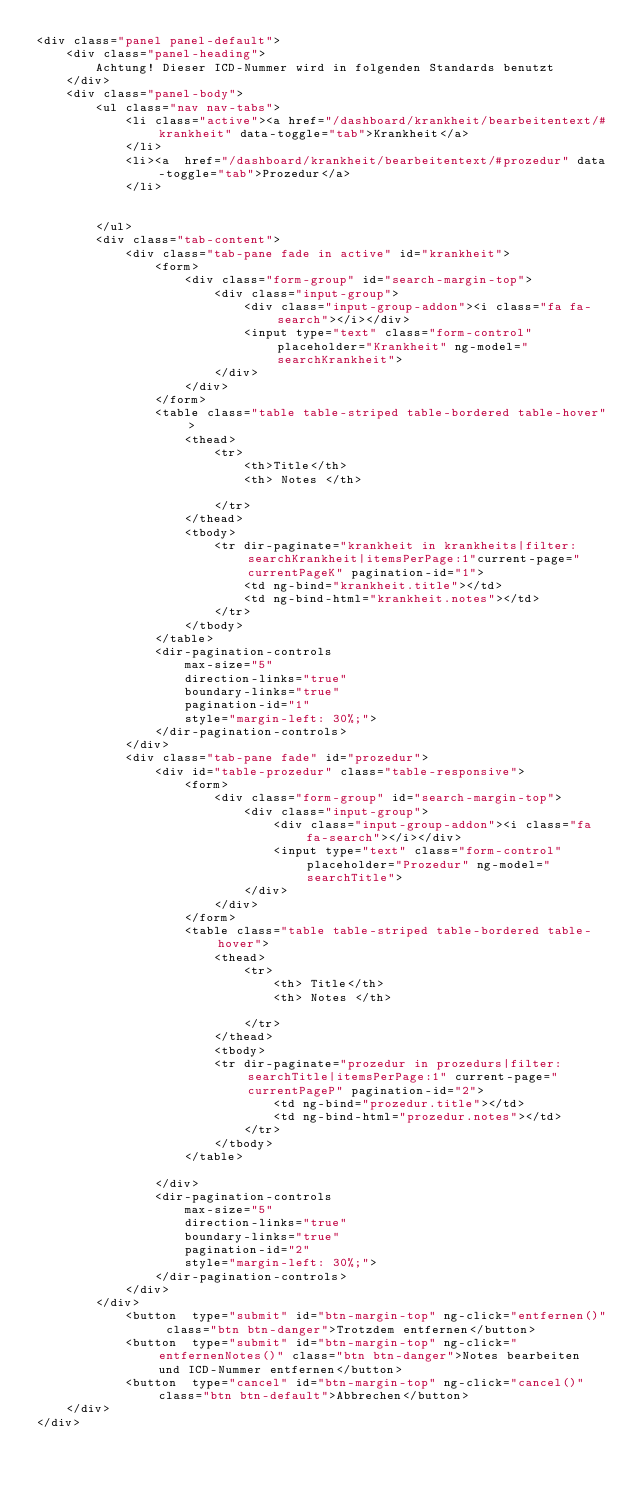Convert code to text. <code><loc_0><loc_0><loc_500><loc_500><_HTML_><div class="panel panel-default">
    <div class="panel-heading">
        Achtung! Dieser ICD-Nummer wird in folgenden Standards benutzt
    </div>
    <div class="panel-body">
        <ul class="nav nav-tabs">
            <li class="active"><a href="/dashboard/krankheit/bearbeitentext/#krankheit" data-toggle="tab">Krankheit</a>
            </li>
            <li><a  href="/dashboard/krankheit/bearbeitentext/#prozedur" data-toggle="tab">Prozedur</a>
            </li>


        </ul>
        <div class="tab-content">
            <div class="tab-pane fade in active" id="krankheit">
                <form>
                    <div class="form-group" id="search-margin-top">
                        <div class="input-group">
                            <div class="input-group-addon"><i class="fa fa-search"></i></div>
                            <input type="text" class="form-control" placeholder="Krankheit" ng-model="searchKrankheit">
                        </div>      
                    </div>
                </form>
                <table class="table table-striped table-bordered table-hover">
                    <thead>
                        <tr>
                            <th>Title</th>
                            <th> Notes </th>

                        </tr>
                    </thead>
                    <tbody>
                        <tr dir-paginate="krankheit in krankheits|filter:searchKrankheit|itemsPerPage:1"current-page="currentPageK" pagination-id="1">
                            <td ng-bind="krankheit.title"></td>
                            <td ng-bind-html="krankheit.notes"></td>
                        </tr>
                    </tbody>
                </table>
                <dir-pagination-controls
                    max-size="5"
                    direction-links="true"
                    boundary-links="true"
                    pagination-id="1"
                    style="margin-left: 30%;">
                </dir-pagination-controls>
            </div>
            <div class="tab-pane fade" id="prozedur">
                <div id="table-prozedur" class="table-responsive">
                    <form>
                        <div class="form-group" id="search-margin-top">
                            <div class="input-group">
                                <div class="input-group-addon"><i class="fa fa-search"></i></div>
                                <input type="text" class="form-control" placeholder="Prozedur" ng-model="searchTitle">
                            </div>      
                        </div>
                    </form>
                    <table class="table table-striped table-bordered table-hover">
                        <thead>
                            <tr>
                                <th> Title</th>
                                <th> Notes </th>

                            </tr>
                        </thead>
                        <tbody>
                        <tr dir-paginate="prozedur in prozedurs|filter:searchTitle|itemsPerPage:1" current-page="currentPageP" pagination-id="2">
                                <td ng-bind="prozedur.title"></td>
                                <td ng-bind-html="prozedur.notes"></td>
                            </tr>
                        </tbody>
                    </table>

                </div>
                <dir-pagination-controls
                    max-size="5"
                    direction-links="true"
                    boundary-links="true"
                    pagination-id="2"
                    style="margin-left: 30%;">
                </dir-pagination-controls>
            </div>
        </div>
            <button  type="submit" id="btn-margin-top" ng-click="entfernen()" class="btn btn-danger">Trotzdem entfernen</button>
            <button  type="submit" id="btn-margin-top" ng-click="entfernenNotes()" class="btn btn-danger">Notes bearbeiten und ICD-Nummer entfernen</button>
            <button  type="cancel" id="btn-margin-top" ng-click="cancel()" class="btn btn-default">Abbrechen</button>
    </div>
</div>

</code> 